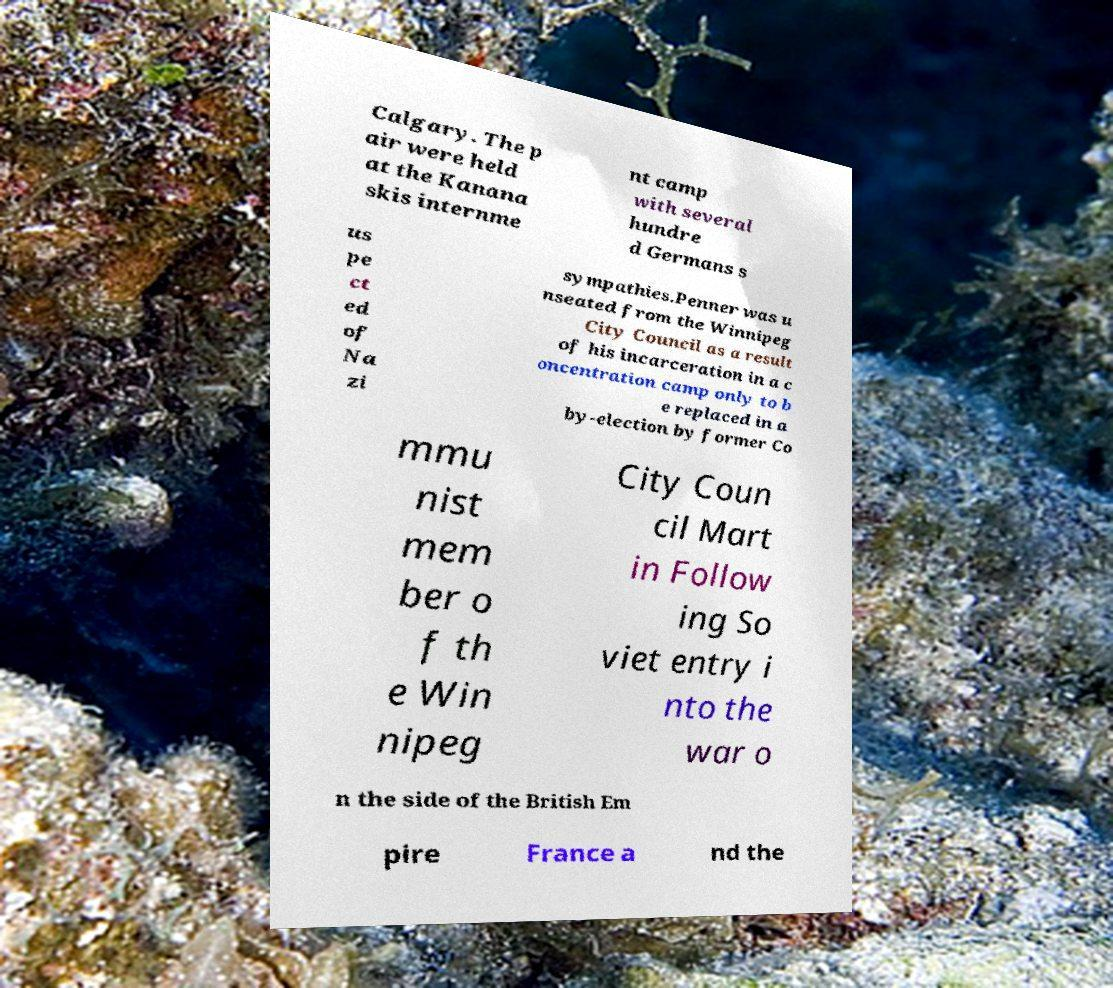I need the written content from this picture converted into text. Can you do that? Calgary. The p air were held at the Kanana skis internme nt camp with several hundre d Germans s us pe ct ed of Na zi sympathies.Penner was u nseated from the Winnipeg City Council as a result of his incarceration in a c oncentration camp only to b e replaced in a by-election by former Co mmu nist mem ber o f th e Win nipeg City Coun cil Mart in Follow ing So viet entry i nto the war o n the side of the British Em pire France a nd the 